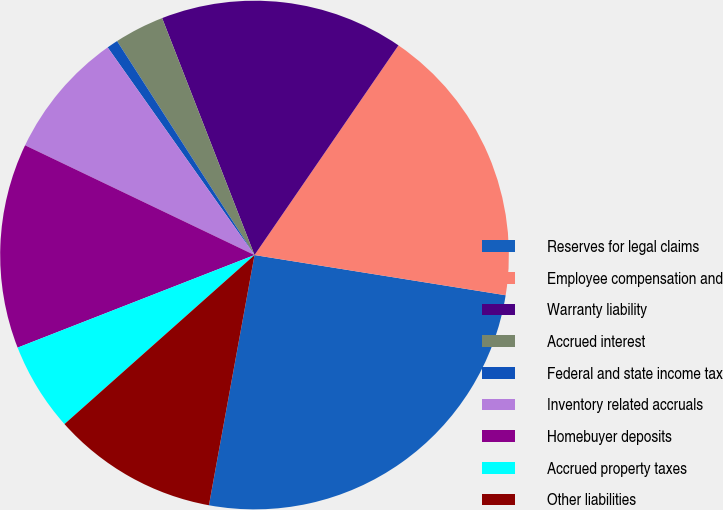Convert chart to OTSL. <chart><loc_0><loc_0><loc_500><loc_500><pie_chart><fcel>Reserves for legal claims<fcel>Employee compensation and<fcel>Warranty liability<fcel>Accrued interest<fcel>Federal and state income tax<fcel>Inventory related accruals<fcel>Homebuyer deposits<fcel>Accrued property taxes<fcel>Other liabilities<nl><fcel>25.34%<fcel>17.95%<fcel>15.49%<fcel>3.17%<fcel>0.71%<fcel>8.1%<fcel>13.03%<fcel>5.64%<fcel>10.56%<nl></chart> 